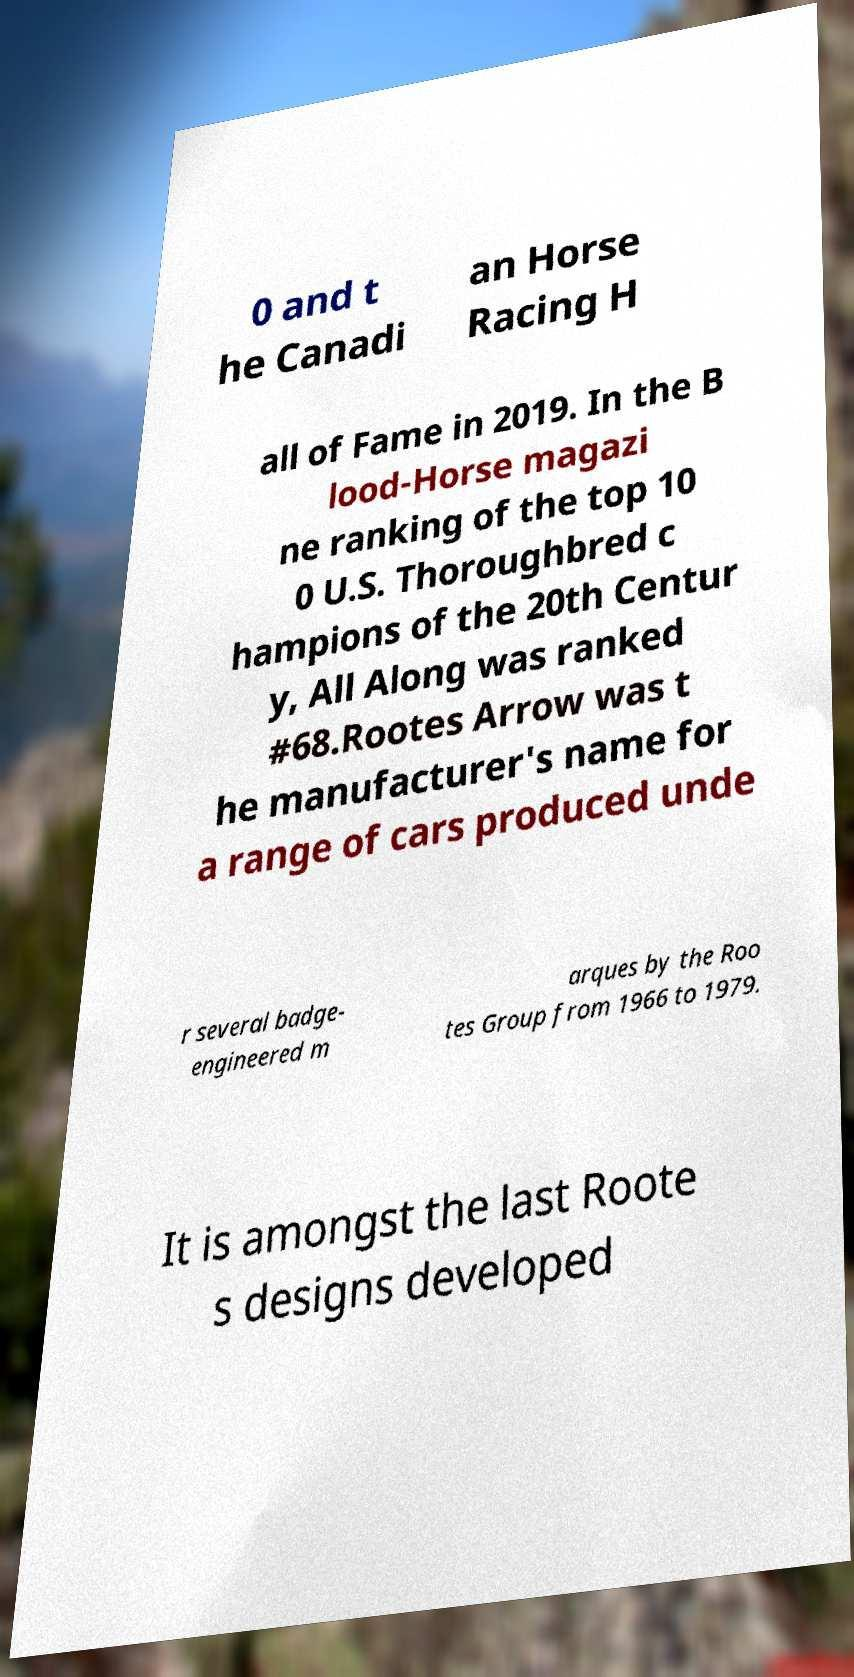Could you extract and type out the text from this image? 0 and t he Canadi an Horse Racing H all of Fame in 2019. In the B lood-Horse magazi ne ranking of the top 10 0 U.S. Thoroughbred c hampions of the 20th Centur y, All Along was ranked #68.Rootes Arrow was t he manufacturer's name for a range of cars produced unde r several badge- engineered m arques by the Roo tes Group from 1966 to 1979. It is amongst the last Roote s designs developed 